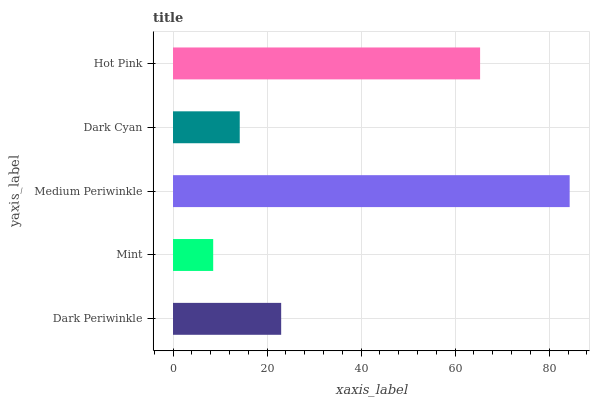Is Mint the minimum?
Answer yes or no. Yes. Is Medium Periwinkle the maximum?
Answer yes or no. Yes. Is Medium Periwinkle the minimum?
Answer yes or no. No. Is Mint the maximum?
Answer yes or no. No. Is Medium Periwinkle greater than Mint?
Answer yes or no. Yes. Is Mint less than Medium Periwinkle?
Answer yes or no. Yes. Is Mint greater than Medium Periwinkle?
Answer yes or no. No. Is Medium Periwinkle less than Mint?
Answer yes or no. No. Is Dark Periwinkle the high median?
Answer yes or no. Yes. Is Dark Periwinkle the low median?
Answer yes or no. Yes. Is Mint the high median?
Answer yes or no. No. Is Medium Periwinkle the low median?
Answer yes or no. No. 